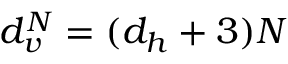Convert formula to latex. <formula><loc_0><loc_0><loc_500><loc_500>d _ { v } ^ { N } = ( d _ { h } + 3 ) N</formula> 